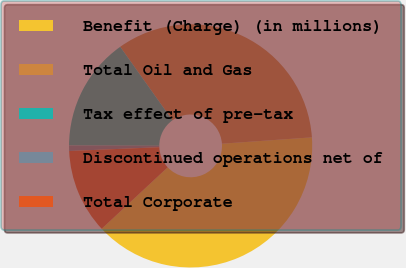Convert chart. <chart><loc_0><loc_0><loc_500><loc_500><pie_chart><fcel>Benefit (Charge) (in millions)<fcel>Total Oil and Gas<fcel>Tax effect of pre-tax<fcel>Discontinued operations net of<fcel>Total Corporate<nl><fcel>39.18%<fcel>33.71%<fcel>15.12%<fcel>0.72%<fcel>11.27%<nl></chart> 